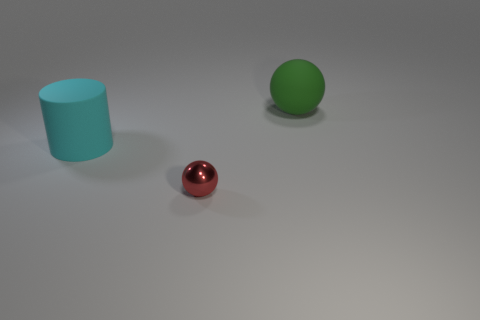The ball that is behind the big object left of the large rubber object behind the large cylinder is what color?
Make the answer very short. Green. There is a large cyan matte object; is it the same shape as the big object that is on the right side of the red metallic sphere?
Make the answer very short. No. What color is the object that is both in front of the matte ball and right of the big cyan matte object?
Your answer should be very brief. Red. Is there a tiny gray thing of the same shape as the small red shiny object?
Provide a succinct answer. No. Does the big matte ball have the same color as the rubber cylinder?
Your answer should be very brief. No. There is a matte thing behind the big cyan matte object; is there a big green thing that is in front of it?
Ensure brevity in your answer.  No. How many objects are either objects behind the big cyan matte thing or things that are left of the big green object?
Offer a terse response. 3. What number of objects are either tiny metallic cubes or large cyan matte cylinders that are left of the big green rubber sphere?
Offer a very short reply. 1. What size is the sphere that is right of the sphere in front of the large thing to the right of the large cyan rubber object?
Offer a very short reply. Large. There is a green object that is the same size as the cyan object; what is its material?
Your answer should be compact. Rubber. 